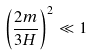Convert formula to latex. <formula><loc_0><loc_0><loc_500><loc_500>\left ( \frac { 2 m } { 3 H } \right ) ^ { 2 } \ll 1</formula> 